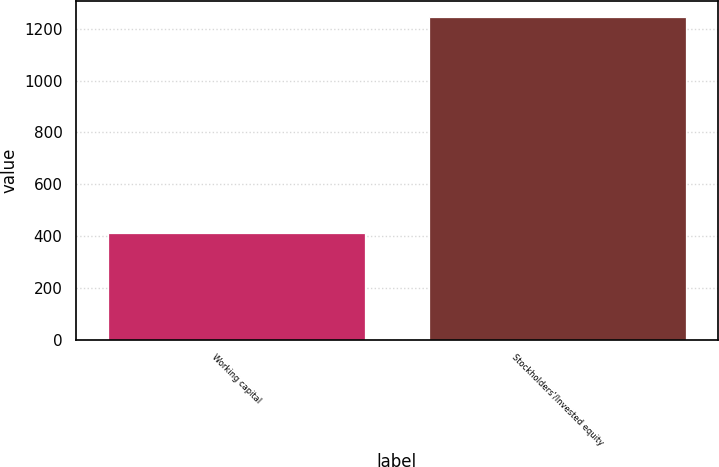<chart> <loc_0><loc_0><loc_500><loc_500><bar_chart><fcel>Working capital<fcel>Stockholders'/Invested equity<nl><fcel>412<fcel>1245<nl></chart> 